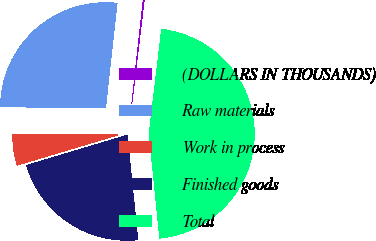Convert chart to OTSL. <chart><loc_0><loc_0><loc_500><loc_500><pie_chart><fcel>(DOLLARS IN THOUSANDS)<fcel>Raw materials<fcel>Work in process<fcel>Finished goods<fcel>Total<nl><fcel>0.14%<fcel>26.61%<fcel>4.78%<fcel>21.97%<fcel>46.5%<nl></chart> 